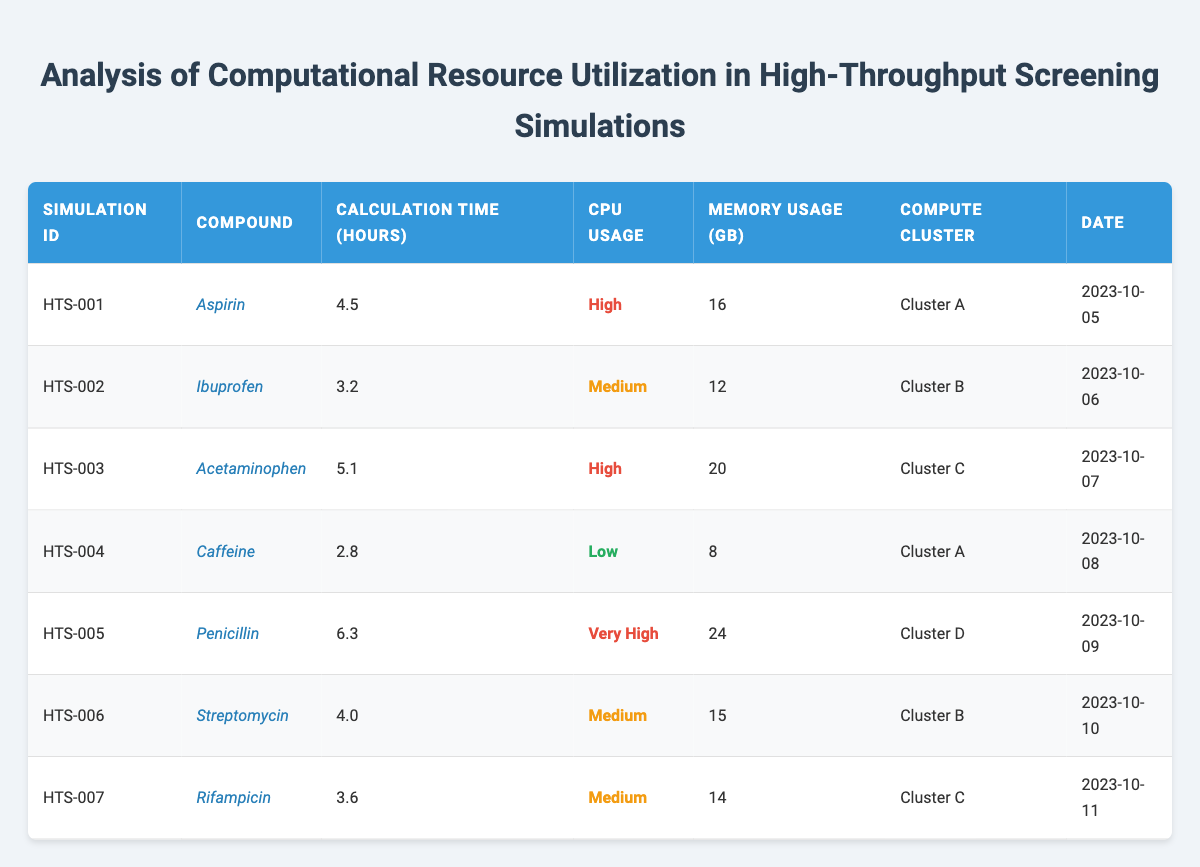What is the total calculation time for all simulations? To find the total calculation time, sum the calculation times for each simulation: 4.5 + 3.2 + 5.1 + 2.8 + 6.3 + 4.0 + 3.6 = 29.5 hours.
Answer: 29.5 hours How many simulations were performed on "Cluster A"? Referring to the table, "Cluster A" appears for "Aspirin" and "Caffeine," which means there are 2 simulations on "Cluster A".
Answer: 2 What is the average memory usage of the simulations? Sum the memory usage values: 16 + 12 + 20 + 8 + 24 + 15 + 14 = 109. There are 7 simulations, so the average memory usage is 109 / 7 ≈ 15.57 GB.
Answer: 15.57 GB Is "Penicillin" the compound with the highest calculation time? The calculation time for "Penicillin" is 6.3 hours, which is compared against other compounds. The highest calculation time is 6.3 hours (for "Penicillin"), confirming it is indeed the highest.
Answer: Yes What is the ratio of high CPU usage simulations to low CPU usage simulations? There are 3 high (Aspirin, Acetaminophen, Penicillin) and 1 low (Caffeine) CPU usage simulations. The ratio is 3:1.
Answer: 3:1 Which compound had the least memory usage, and what was the value? The compound with the least memory usage is "Caffeine" with 8 GB.
Answer: Caffeine, 8 GB Did all simulations exceed a calculation time of 2 hours? All simulation times are listed: 4.5, 3.2, 5.1, 2.8, 6.3, 4.0, and 3.6 hours. The lowest is 2.8 hours, so not all exceed 2 hours.
Answer: No What is the total memory usage for compounds with "Medium" CPU usage? The compounds with medium CPU usage are "Ibuprofen," "Streptomycin," and "Rifampicin" with memory of 12 GB, 15 GB, and 14 GB respectively. The total is 12 + 15 + 14 = 41 GB.
Answer: 41 GB How many days were between the first and last simulation date? The first simulation was on 2023-10-05, and the last one was on 2023-10-11. Counting the days in between gives 6 days total (including both end dates).
Answer: 6 days Which compute cluster handled the highest memory usage, and what was that usage? "Penicillin" used the most memory at 24 GB, which was run on "Cluster D"—the highest memory usage in the table.
Answer: Cluster D, 24 GB 